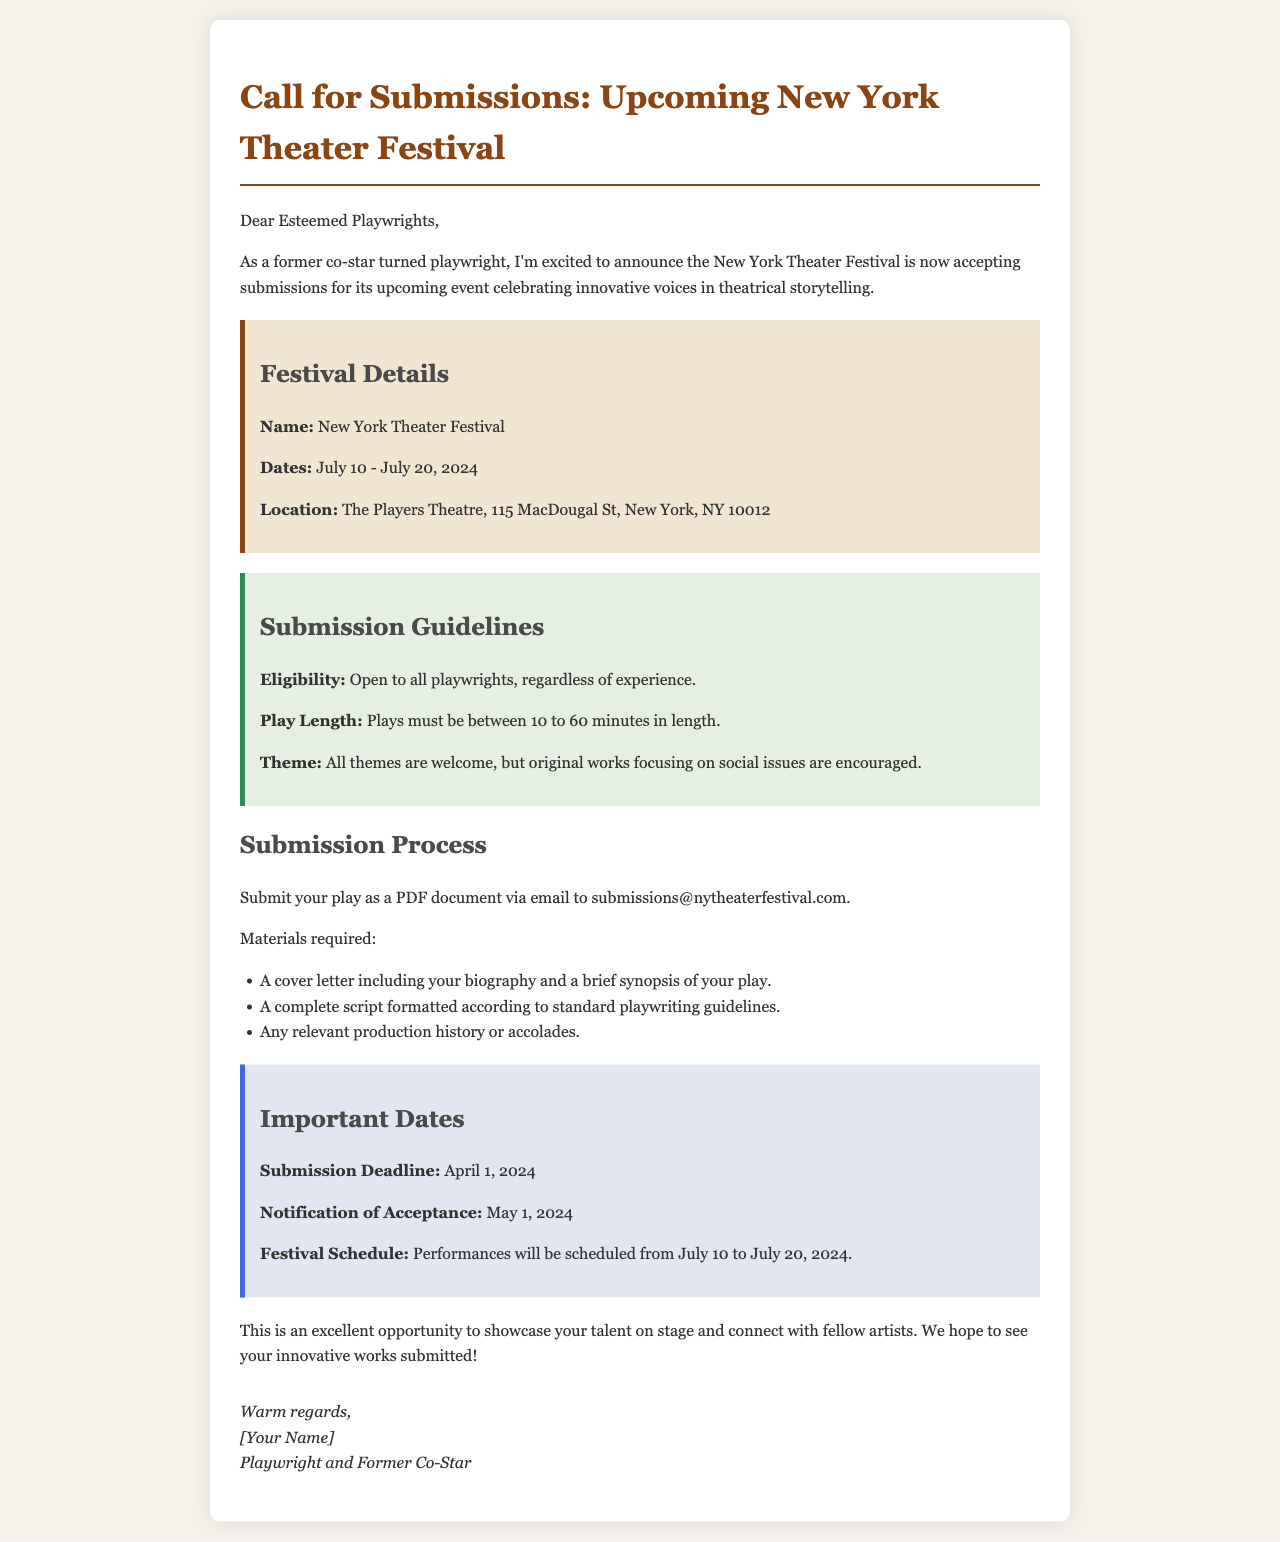What are the festival dates? The festival dates are clearly stated in the document as July 10 - July 20, 2024.
Answer: July 10 - July 20, 2024 Where will the festival be held? The location is specified in the document as The Players Theatre, 115 MacDougal St, New York, NY 10012.
Answer: The Players Theatre, 115 MacDougal St, New York, NY 10012 What is the submission deadline? The deadline for submissions is mentioned as April 1, 2024.
Answer: April 1, 2024 What is the maximum play length? The maximum length of the plays is stated in the submission guidelines as 60 minutes.
Answer: 60 minutes What types of plays are encouraged? The document indicates that original works focusing on social issues are encouraged.
Answer: Original works focusing on social issues What materials are required for submission? The required materials include a cover letter, a complete script, and any relevant production history or accolades.
Answer: A cover letter, a complete script, and any relevant production history or accolades Who can submit plays? The eligibility criterion mentioned in the document states that it is open to all playwrights, regardless of experience.
Answer: All playwrights, regardless of experience When will acceptance notifications be sent? According to the important dates, notifications of acceptance will be sent on May 1, 2024.
Answer: May 1, 2024 